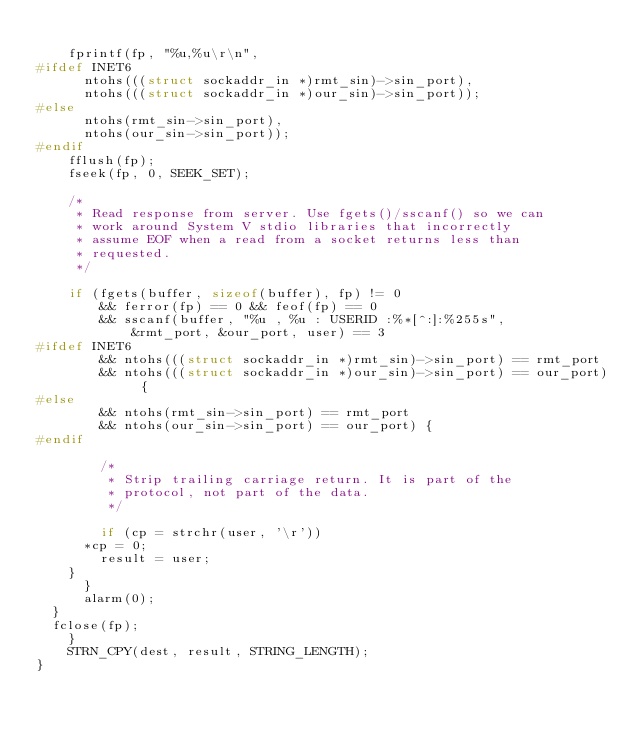Convert code to text. <code><loc_0><loc_0><loc_500><loc_500><_C_>
		fprintf(fp, "%u,%u\r\n",
#ifdef INET6
			ntohs(((struct sockaddr_in *)rmt_sin)->sin_port),
			ntohs(((struct sockaddr_in *)our_sin)->sin_port));
#else
			ntohs(rmt_sin->sin_port),
			ntohs(our_sin->sin_port));
#endif
		fflush(fp);
		fseek(fp, 0, SEEK_SET);

		/*
		 * Read response from server. Use fgets()/sscanf() so we can
		 * work around System V stdio libraries that incorrectly
		 * assume EOF when a read from a socket returns less than
		 * requested.
		 */

		if (fgets(buffer, sizeof(buffer), fp) != 0
		    && ferror(fp) == 0 && feof(fp) == 0
		    && sscanf(buffer, "%u , %u : USERID :%*[^:]:%255s",
			      &rmt_port, &our_port, user) == 3
#ifdef INET6
		    && ntohs(((struct sockaddr_in *)rmt_sin)->sin_port) == rmt_port
		    && ntohs(((struct sockaddr_in *)our_sin)->sin_port) == our_port) {
#else
		    && ntohs(rmt_sin->sin_port) == rmt_port
		    && ntohs(our_sin->sin_port) == our_port) {
#endif

		    /*
		     * Strip trailing carriage return. It is part of the
		     * protocol, not part of the data.
		     */

		    if (cp = strchr(user, '\r'))
			*cp = 0;
		    result = user;
		}
	    }
	    alarm(0);
	}
	fclose(fp);
    }
    STRN_CPY(dest, result, STRING_LENGTH);
}
</code> 